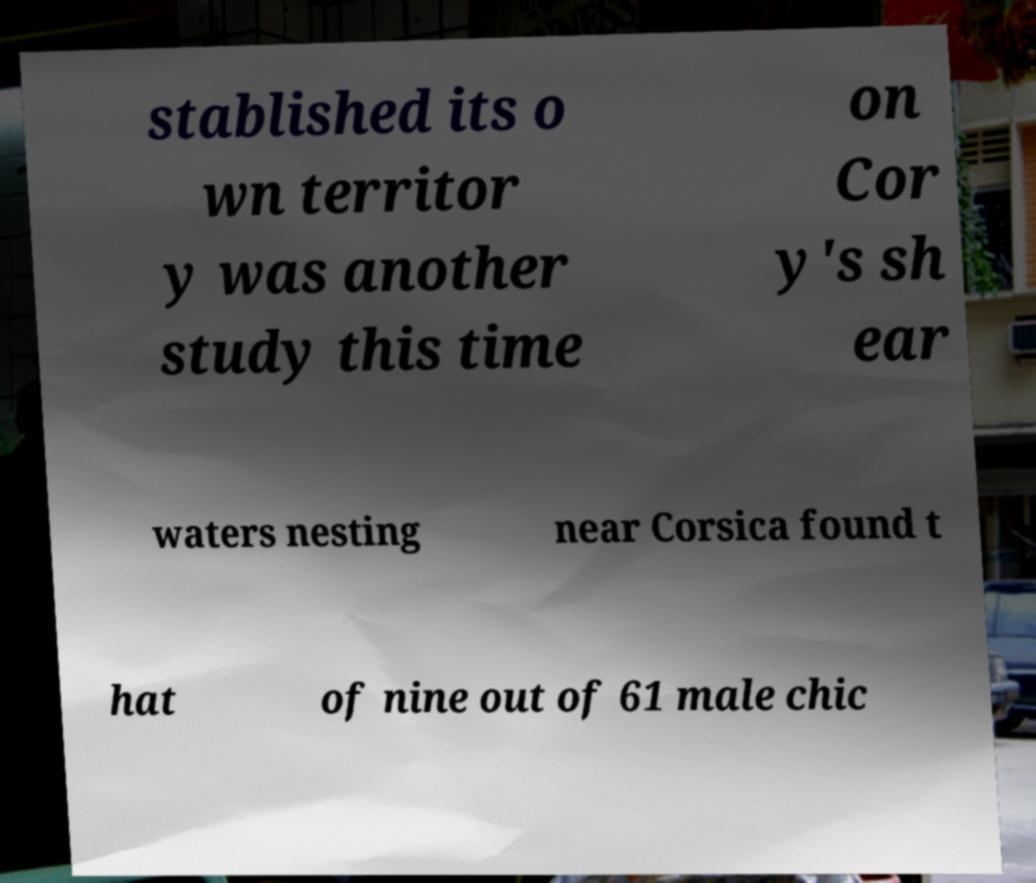I need the written content from this picture converted into text. Can you do that? stablished its o wn territor y was another study this time on Cor y's sh ear waters nesting near Corsica found t hat of nine out of 61 male chic 